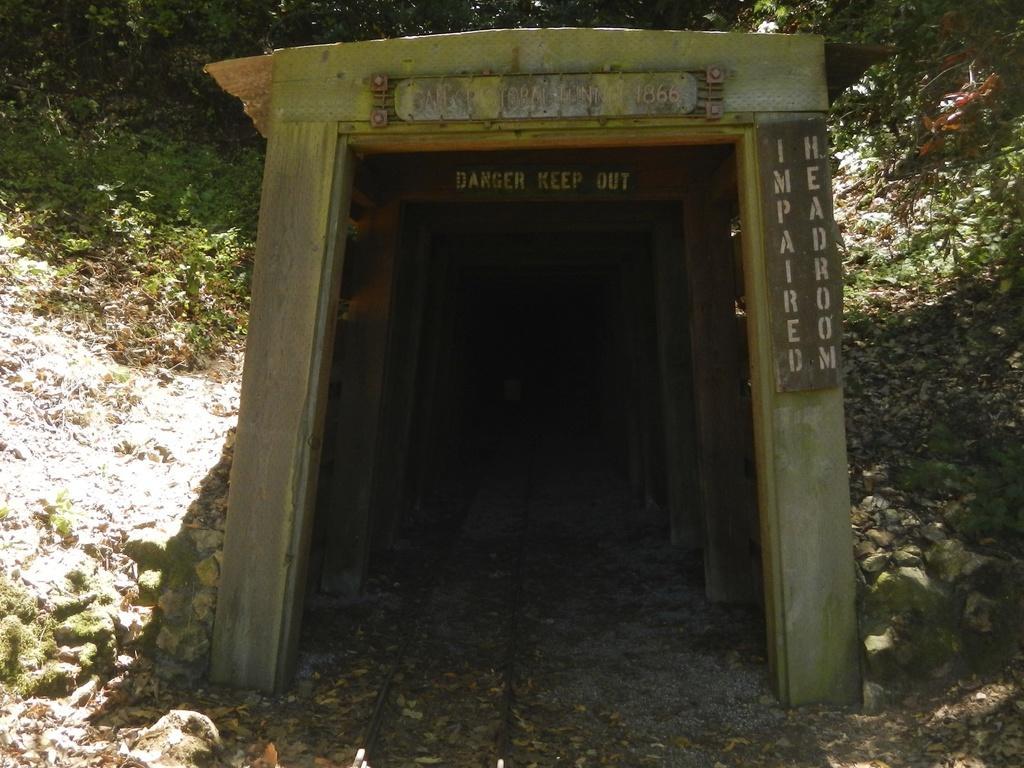In one or two sentences, can you explain what this image depicts? In this picture there is a tunnel in the center. In the tunnel there is a track. In the background there are plants and stones. 